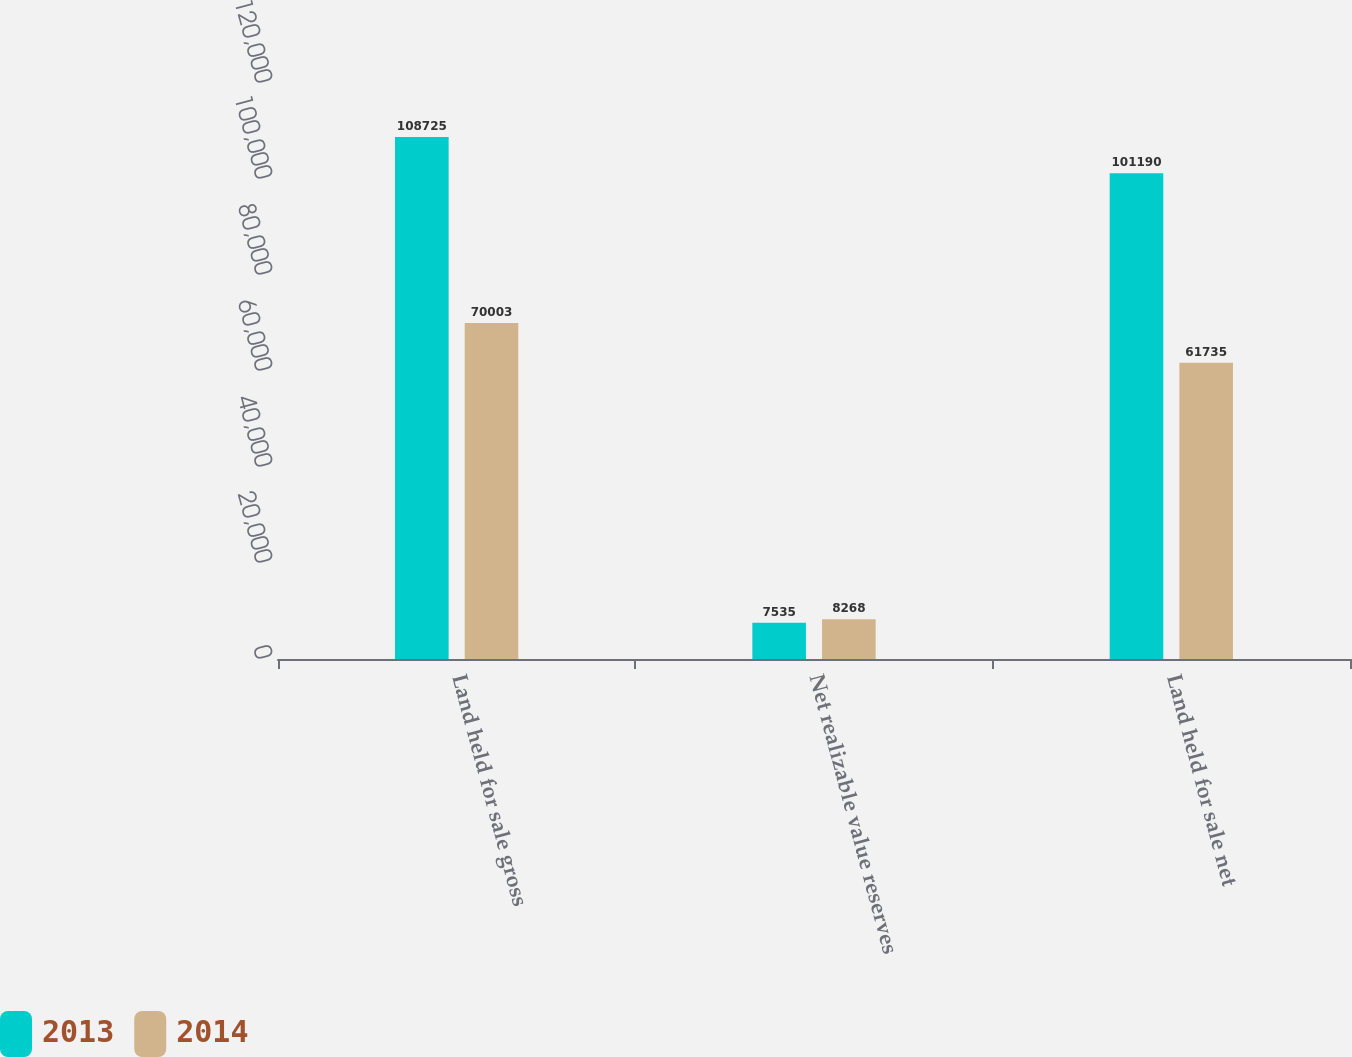Convert chart. <chart><loc_0><loc_0><loc_500><loc_500><stacked_bar_chart><ecel><fcel>Land held for sale gross<fcel>Net realizable value reserves<fcel>Land held for sale net<nl><fcel>2013<fcel>108725<fcel>7535<fcel>101190<nl><fcel>2014<fcel>70003<fcel>8268<fcel>61735<nl></chart> 